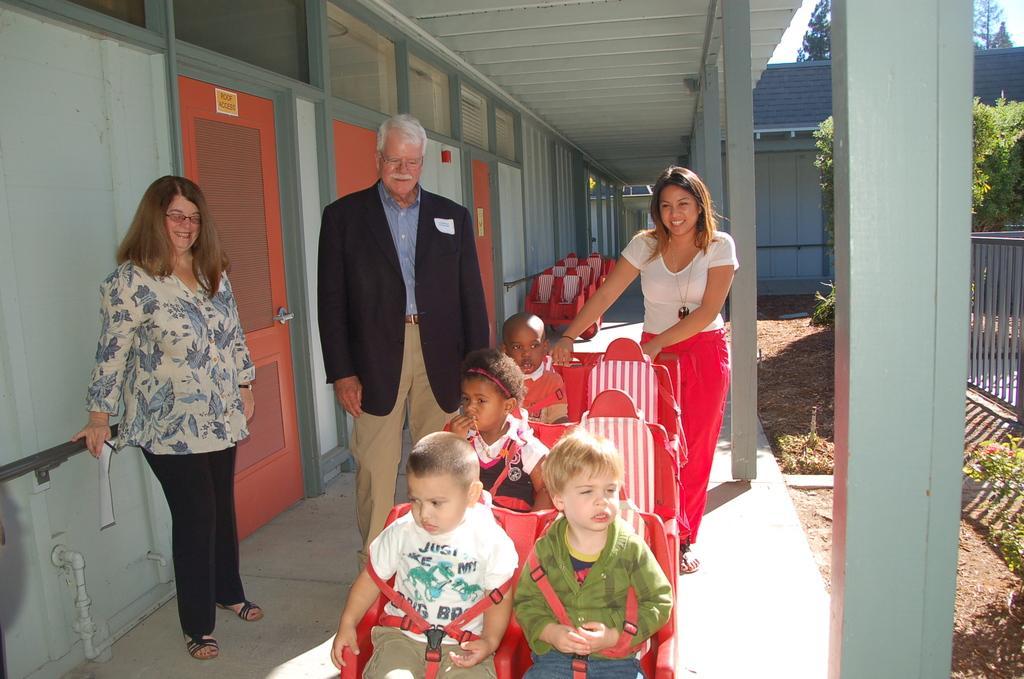Describe this image in one or two sentences. In this image there are three persons standing with a smile on their face, in front of them there are children sitting on the chairs. On the left side of the image there is a building. At the top of the image there is a metal shed and on the right side of the image there are pillars of a building, railing and trees. 